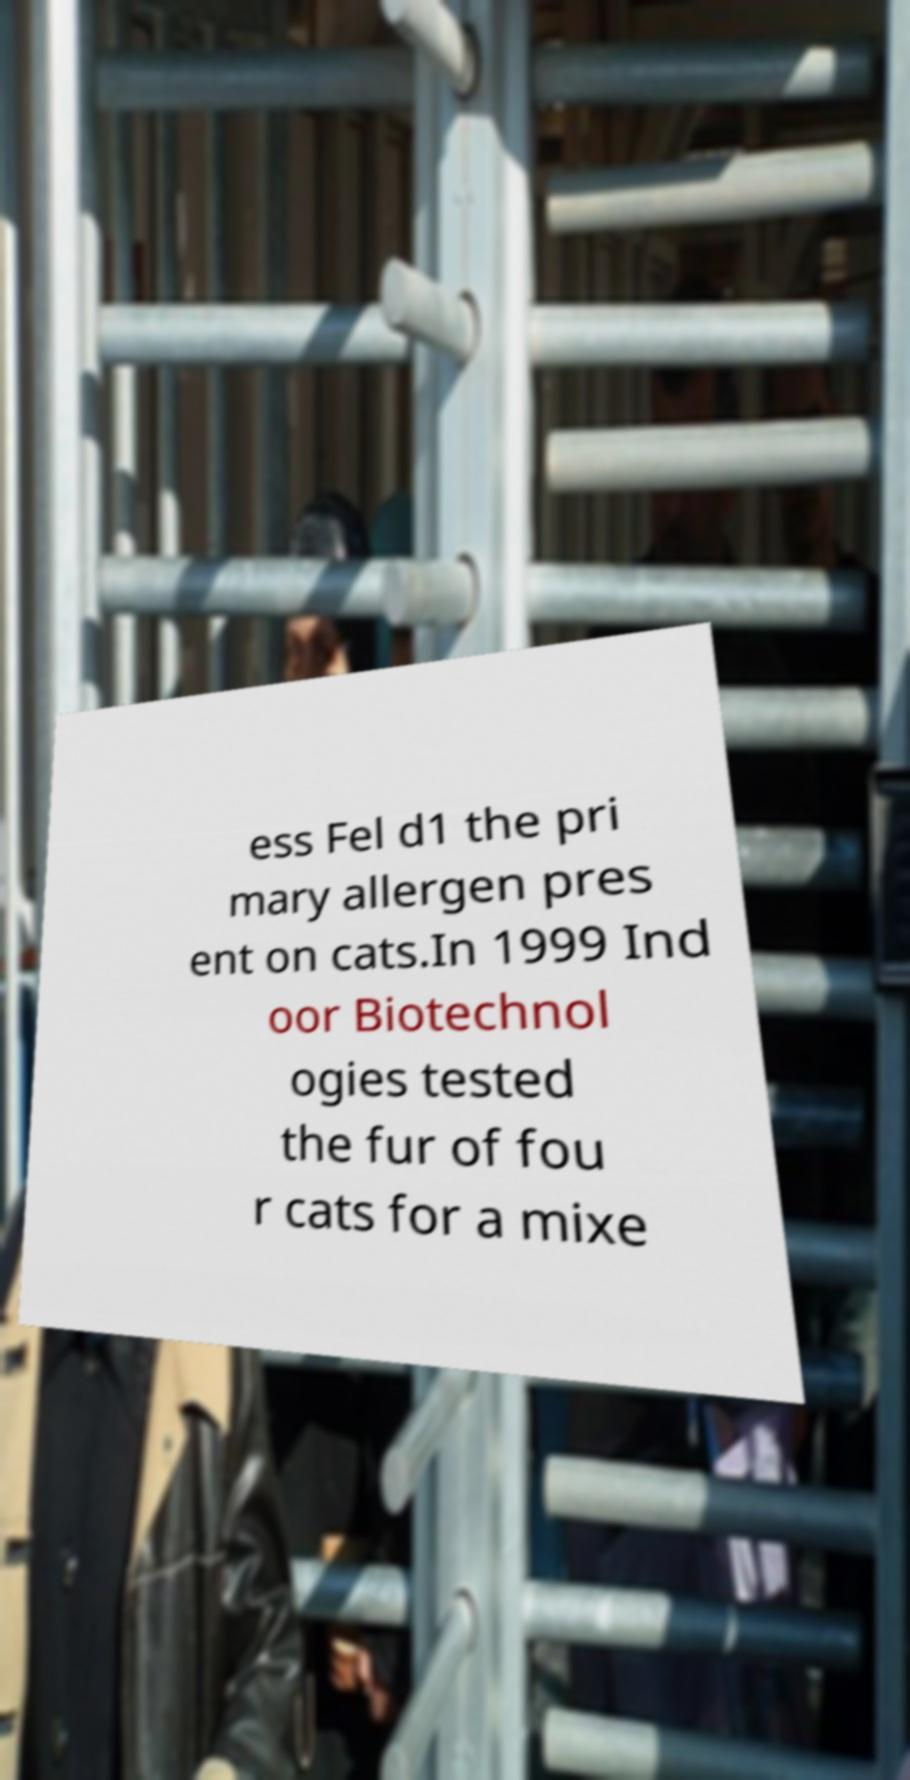Could you extract and type out the text from this image? ess Fel d1 the pri mary allergen pres ent on cats.In 1999 Ind oor Biotechnol ogies tested the fur of fou r cats for a mixe 